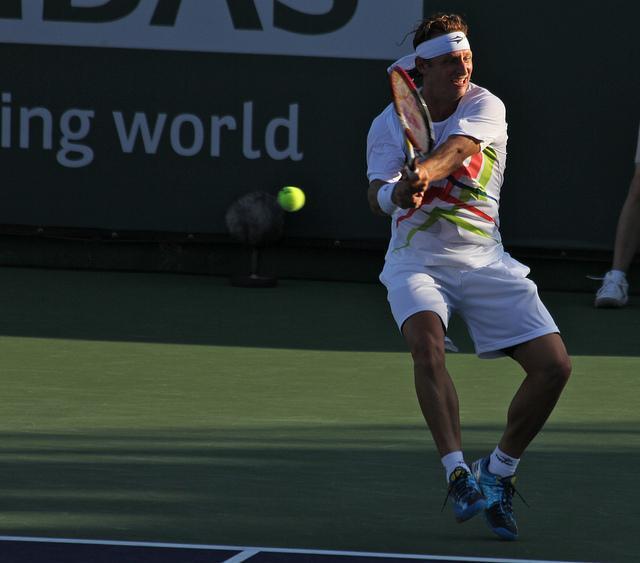How many balls is this tennis player throwing up?
Give a very brief answer. 1. How many people are visible?
Give a very brief answer. 2. 